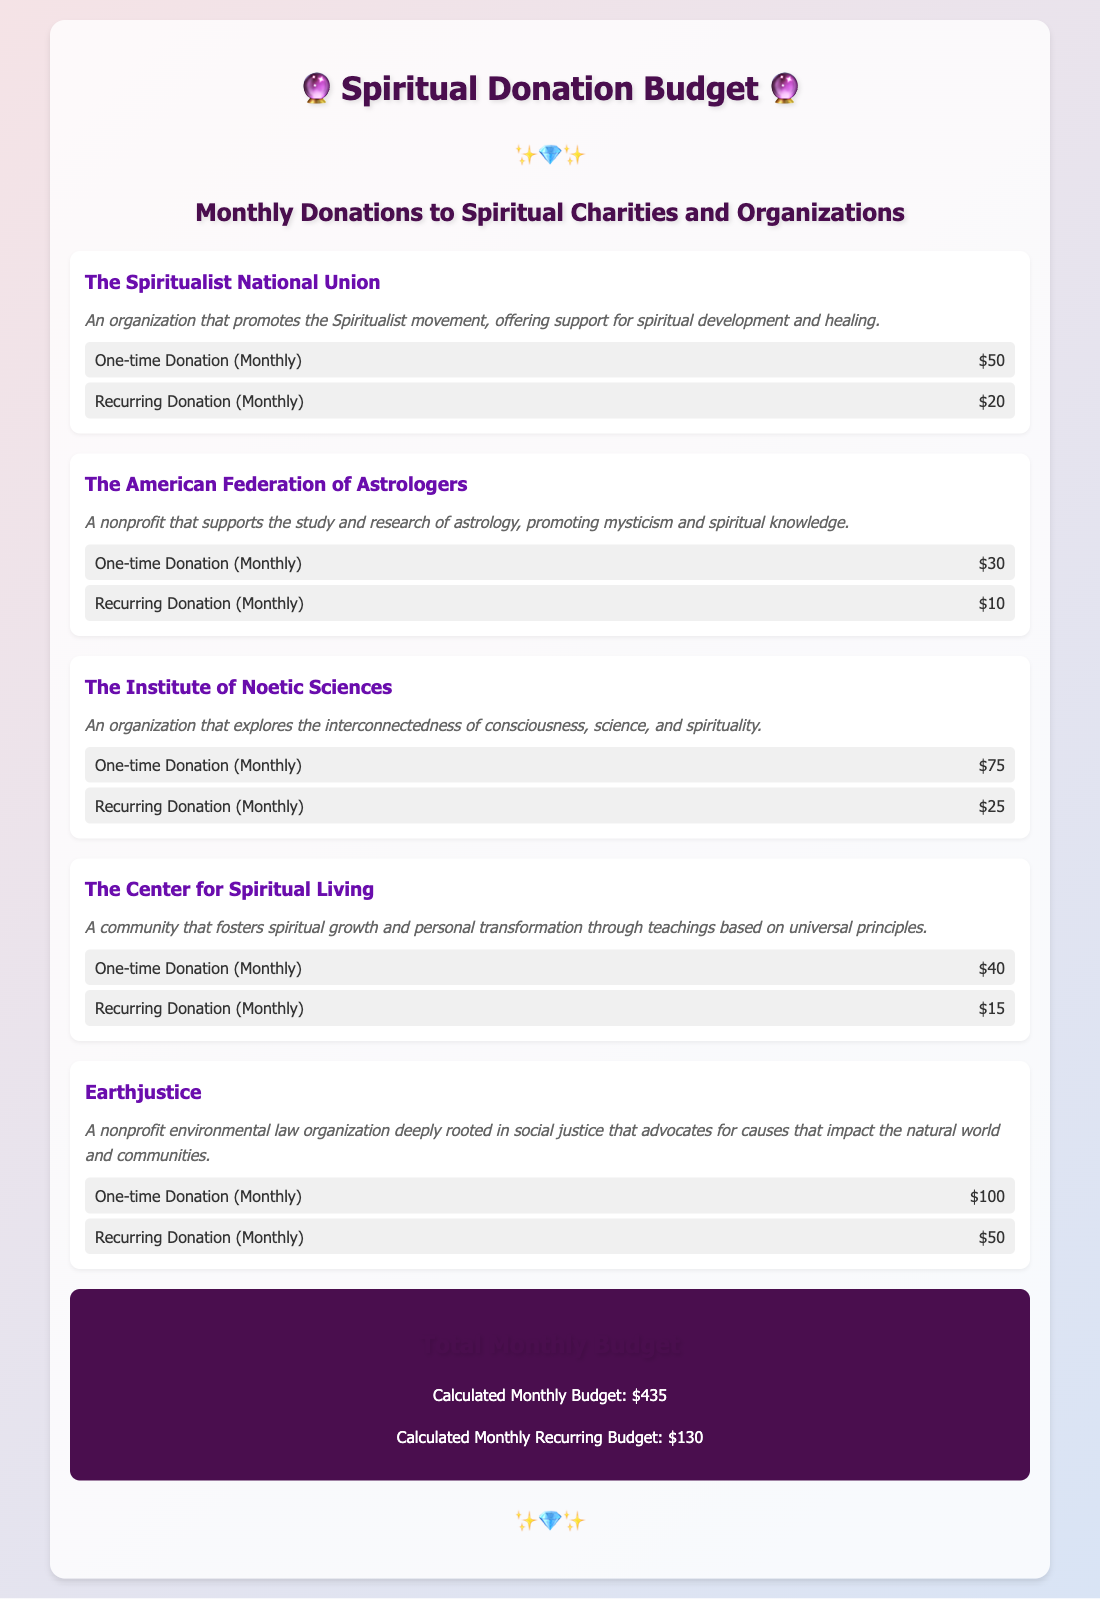What is the name of the first organization listed? The first organization in the document is "The Spiritualist National Union."
Answer: The Spiritualist National Union How much is the one-time donation for Earthjustice? The document states Earthjustice has a one-time donation of $100.
Answer: $100 What is the total monthly budget calculated? The total monthly budget is explicitly mentioned in the document as $435.
Answer: $435 How many organizations are mentioned in the document? There are five organizations detailed in the donation budget.
Answer: Five Which organization has the highest recurring donation amount? The organization with the highest recurring donation is Earthjustice with $50.
Answer: Earthjustice What type of donation does The Institute of Noetic Sciences offer? The Institute of Noetic Sciences offers both one-time and recurring donations.
Answer: One-time and recurring What is the donation amount for The American Federation of Astrologers for a recurring donation? The recurring donation amount for The American Federation of Astrologers is specified as $10.
Answer: $10 What is the common theme among these organizations? All organizations are focused on spiritual development, community support, and social justice.
Answer: Spiritual development and community support What is the recurring donation for The Center for Spiritual Living? The recurring donation amount for The Center for Spiritual Living is $15.
Answer: $15 